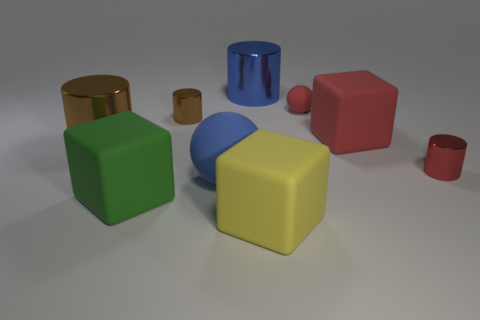There is a tiny red object that is the same shape as the tiny brown metal thing; what is it made of?
Keep it short and to the point. Metal. Is the large blue thing that is in front of the red metal thing made of the same material as the big green object?
Your response must be concise. Yes. Are there more large yellow rubber things that are behind the green object than small cylinders that are in front of the large brown shiny cylinder?
Ensure brevity in your answer.  No. What size is the yellow block?
Give a very brief answer. Large. What is the shape of the tiny object that is made of the same material as the green block?
Your response must be concise. Sphere. There is a large rubber thing that is behind the red shiny object; does it have the same shape as the red shiny object?
Your answer should be compact. No. How many objects are either big gray shiny things or metallic objects?
Offer a terse response. 4. There is a large thing that is both in front of the large brown thing and behind the green rubber block; what material is it?
Offer a terse response. Rubber. Do the red block and the yellow block have the same size?
Your answer should be very brief. Yes. What size is the sphere in front of the rubber cube that is to the right of the small ball?
Your response must be concise. Large. 